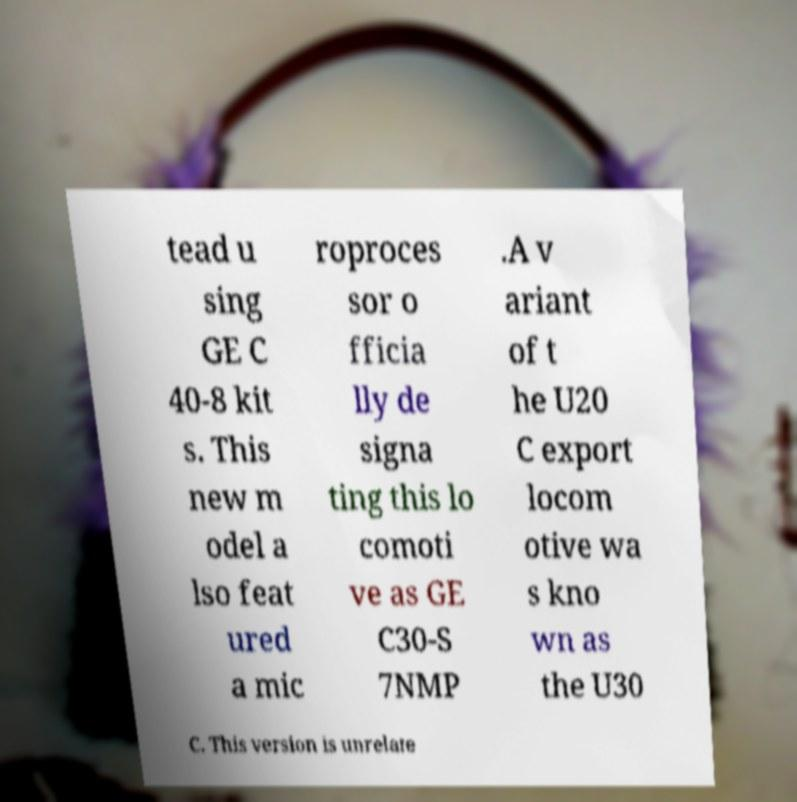What messages or text are displayed in this image? I need them in a readable, typed format. tead u sing GE C 40-8 kit s. This new m odel a lso feat ured a mic roproces sor o fficia lly de signa ting this lo comoti ve as GE C30-S 7NMP .A v ariant of t he U20 C export locom otive wa s kno wn as the U30 C. This version is unrelate 